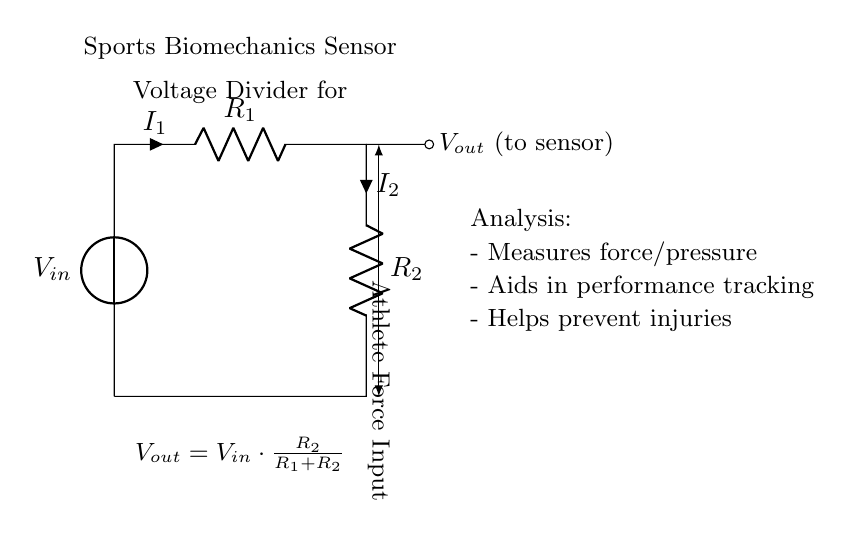What is the input voltage of the circuit? The input voltage, indicated by the label "Vin" next to the voltage source, is the potential supplied to the circuit. Since the circuit diagram does not specify a numerical value, we refer to it as Vin.
Answer: Vin What are the resistances in the circuit? The circuit contains two resistors labeled R1 and R2. These components are specified in the diagram and are key to the voltage divider function within the circuit.
Answer: R1 and R2 What represents the output voltage? The output voltage is represented by the label "Vout" on the right side of the circuit, connected to the second resistor (R2). It indicates the voltage measured at this point in relation to the input.
Answer: Vout How does the output voltage relate to the input voltage? The provided formula "Vout = Vin * (R2 / (R1 + R2))" explains that the output voltage is derived from the input voltage, scaled by the resistance values of R2 and the total resistance (R1 + R2). The relationship dictates that as either resistor's value changes, the output voltage adjusts accordingly.
Answer: Vout = Vin * (R2 / (R1 + R2)) What is the purpose of the voltage divider in this application? The voltage divider helps in sensor applications by measuring force or pressure inputs. It is crucial for performance tracking of athletes, as it enables the analysis of biomechanical aspects through a relatively simple electrical process.
Answer: Measure force/pressure What kind of measurements does this voltage divider facilitate? The analysis section states that the circuit is used to measure force/pressure, track performance, and help prevent injuries, emphasizing its application in sports biomechanics.
Answer: Force/pressure What effect does increasing R1 have on Vout? Increasing R1 increases the total resistance (R1 + R2), which decreases the fraction (R2/(R1 + R2)) in the output voltage formula, leading to a lower Vout for a constant Vin. This relationship demonstrates the dependency of output voltage on the values of the resistors in the voltage divider.
Answer: Decrease Vout 